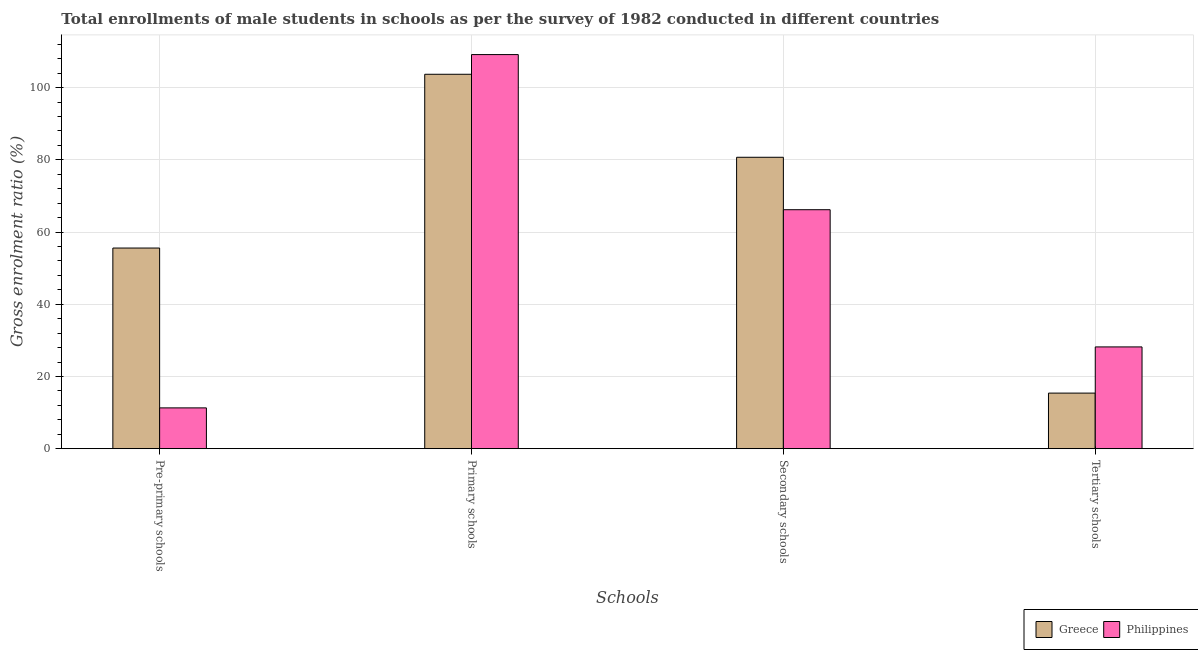How many different coloured bars are there?
Offer a very short reply. 2. How many groups of bars are there?
Make the answer very short. 4. How many bars are there on the 1st tick from the right?
Offer a terse response. 2. What is the label of the 1st group of bars from the left?
Provide a succinct answer. Pre-primary schools. What is the gross enrolment ratio(male) in tertiary schools in Philippines?
Your response must be concise. 28.18. Across all countries, what is the maximum gross enrolment ratio(male) in primary schools?
Provide a succinct answer. 109.14. Across all countries, what is the minimum gross enrolment ratio(male) in secondary schools?
Give a very brief answer. 66.18. In which country was the gross enrolment ratio(male) in primary schools minimum?
Keep it short and to the point. Greece. What is the total gross enrolment ratio(male) in pre-primary schools in the graph?
Provide a succinct answer. 66.86. What is the difference between the gross enrolment ratio(male) in tertiary schools in Philippines and that in Greece?
Give a very brief answer. 12.79. What is the difference between the gross enrolment ratio(male) in secondary schools in Greece and the gross enrolment ratio(male) in pre-primary schools in Philippines?
Your response must be concise. 69.41. What is the average gross enrolment ratio(male) in tertiary schools per country?
Give a very brief answer. 21.79. What is the difference between the gross enrolment ratio(male) in tertiary schools and gross enrolment ratio(male) in secondary schools in Philippines?
Your response must be concise. -38. What is the ratio of the gross enrolment ratio(male) in primary schools in Greece to that in Philippines?
Your answer should be compact. 0.95. Is the gross enrolment ratio(male) in tertiary schools in Philippines less than that in Greece?
Keep it short and to the point. No. Is the difference between the gross enrolment ratio(male) in tertiary schools in Philippines and Greece greater than the difference between the gross enrolment ratio(male) in secondary schools in Philippines and Greece?
Give a very brief answer. Yes. What is the difference between the highest and the second highest gross enrolment ratio(male) in primary schools?
Make the answer very short. 5.46. What is the difference between the highest and the lowest gross enrolment ratio(male) in secondary schools?
Your response must be concise. 14.52. In how many countries, is the gross enrolment ratio(male) in pre-primary schools greater than the average gross enrolment ratio(male) in pre-primary schools taken over all countries?
Your answer should be compact. 1. Is the sum of the gross enrolment ratio(male) in tertiary schools in Greece and Philippines greater than the maximum gross enrolment ratio(male) in primary schools across all countries?
Provide a short and direct response. No. What does the 2nd bar from the left in Tertiary schools represents?
Offer a terse response. Philippines. Is it the case that in every country, the sum of the gross enrolment ratio(male) in pre-primary schools and gross enrolment ratio(male) in primary schools is greater than the gross enrolment ratio(male) in secondary schools?
Give a very brief answer. Yes. What is the difference between two consecutive major ticks on the Y-axis?
Ensure brevity in your answer.  20. Does the graph contain any zero values?
Your response must be concise. No. How many legend labels are there?
Offer a very short reply. 2. What is the title of the graph?
Provide a succinct answer. Total enrollments of male students in schools as per the survey of 1982 conducted in different countries. What is the label or title of the X-axis?
Your answer should be very brief. Schools. What is the label or title of the Y-axis?
Your answer should be compact. Gross enrolment ratio (%). What is the Gross enrolment ratio (%) of Greece in Pre-primary schools?
Offer a terse response. 55.57. What is the Gross enrolment ratio (%) of Philippines in Pre-primary schools?
Offer a terse response. 11.3. What is the Gross enrolment ratio (%) of Greece in Primary schools?
Ensure brevity in your answer.  103.69. What is the Gross enrolment ratio (%) of Philippines in Primary schools?
Your answer should be very brief. 109.14. What is the Gross enrolment ratio (%) of Greece in Secondary schools?
Your answer should be compact. 80.71. What is the Gross enrolment ratio (%) of Philippines in Secondary schools?
Offer a terse response. 66.18. What is the Gross enrolment ratio (%) in Greece in Tertiary schools?
Offer a very short reply. 15.39. What is the Gross enrolment ratio (%) of Philippines in Tertiary schools?
Your answer should be very brief. 28.18. Across all Schools, what is the maximum Gross enrolment ratio (%) in Greece?
Ensure brevity in your answer.  103.69. Across all Schools, what is the maximum Gross enrolment ratio (%) in Philippines?
Give a very brief answer. 109.14. Across all Schools, what is the minimum Gross enrolment ratio (%) in Greece?
Give a very brief answer. 15.39. Across all Schools, what is the minimum Gross enrolment ratio (%) in Philippines?
Provide a short and direct response. 11.3. What is the total Gross enrolment ratio (%) of Greece in the graph?
Give a very brief answer. 255.35. What is the total Gross enrolment ratio (%) of Philippines in the graph?
Keep it short and to the point. 214.81. What is the difference between the Gross enrolment ratio (%) of Greece in Pre-primary schools and that in Primary schools?
Your answer should be very brief. -48.12. What is the difference between the Gross enrolment ratio (%) in Philippines in Pre-primary schools and that in Primary schools?
Offer a terse response. -97.85. What is the difference between the Gross enrolment ratio (%) in Greece in Pre-primary schools and that in Secondary schools?
Your answer should be very brief. -25.14. What is the difference between the Gross enrolment ratio (%) of Philippines in Pre-primary schools and that in Secondary schools?
Make the answer very short. -54.88. What is the difference between the Gross enrolment ratio (%) of Greece in Pre-primary schools and that in Tertiary schools?
Give a very brief answer. 40.17. What is the difference between the Gross enrolment ratio (%) of Philippines in Pre-primary schools and that in Tertiary schools?
Your answer should be compact. -16.89. What is the difference between the Gross enrolment ratio (%) of Greece in Primary schools and that in Secondary schools?
Offer a very short reply. 22.98. What is the difference between the Gross enrolment ratio (%) in Philippines in Primary schools and that in Secondary schools?
Keep it short and to the point. 42.96. What is the difference between the Gross enrolment ratio (%) in Greece in Primary schools and that in Tertiary schools?
Provide a succinct answer. 88.3. What is the difference between the Gross enrolment ratio (%) in Philippines in Primary schools and that in Tertiary schools?
Ensure brevity in your answer.  80.96. What is the difference between the Gross enrolment ratio (%) of Greece in Secondary schools and that in Tertiary schools?
Give a very brief answer. 65.31. What is the difference between the Gross enrolment ratio (%) in Philippines in Secondary schools and that in Tertiary schools?
Offer a terse response. 38. What is the difference between the Gross enrolment ratio (%) of Greece in Pre-primary schools and the Gross enrolment ratio (%) of Philippines in Primary schools?
Your answer should be very brief. -53.58. What is the difference between the Gross enrolment ratio (%) in Greece in Pre-primary schools and the Gross enrolment ratio (%) in Philippines in Secondary schools?
Keep it short and to the point. -10.61. What is the difference between the Gross enrolment ratio (%) of Greece in Pre-primary schools and the Gross enrolment ratio (%) of Philippines in Tertiary schools?
Offer a terse response. 27.38. What is the difference between the Gross enrolment ratio (%) of Greece in Primary schools and the Gross enrolment ratio (%) of Philippines in Secondary schools?
Offer a very short reply. 37.51. What is the difference between the Gross enrolment ratio (%) in Greece in Primary schools and the Gross enrolment ratio (%) in Philippines in Tertiary schools?
Provide a succinct answer. 75.51. What is the difference between the Gross enrolment ratio (%) of Greece in Secondary schools and the Gross enrolment ratio (%) of Philippines in Tertiary schools?
Offer a very short reply. 52.52. What is the average Gross enrolment ratio (%) in Greece per Schools?
Your answer should be compact. 63.84. What is the average Gross enrolment ratio (%) in Philippines per Schools?
Your answer should be very brief. 53.7. What is the difference between the Gross enrolment ratio (%) of Greece and Gross enrolment ratio (%) of Philippines in Pre-primary schools?
Keep it short and to the point. 44.27. What is the difference between the Gross enrolment ratio (%) in Greece and Gross enrolment ratio (%) in Philippines in Primary schools?
Offer a terse response. -5.46. What is the difference between the Gross enrolment ratio (%) of Greece and Gross enrolment ratio (%) of Philippines in Secondary schools?
Your answer should be very brief. 14.52. What is the difference between the Gross enrolment ratio (%) in Greece and Gross enrolment ratio (%) in Philippines in Tertiary schools?
Provide a succinct answer. -12.79. What is the ratio of the Gross enrolment ratio (%) of Greece in Pre-primary schools to that in Primary schools?
Your answer should be very brief. 0.54. What is the ratio of the Gross enrolment ratio (%) in Philippines in Pre-primary schools to that in Primary schools?
Ensure brevity in your answer.  0.1. What is the ratio of the Gross enrolment ratio (%) of Greece in Pre-primary schools to that in Secondary schools?
Provide a succinct answer. 0.69. What is the ratio of the Gross enrolment ratio (%) of Philippines in Pre-primary schools to that in Secondary schools?
Make the answer very short. 0.17. What is the ratio of the Gross enrolment ratio (%) of Greece in Pre-primary schools to that in Tertiary schools?
Offer a terse response. 3.61. What is the ratio of the Gross enrolment ratio (%) of Philippines in Pre-primary schools to that in Tertiary schools?
Your answer should be very brief. 0.4. What is the ratio of the Gross enrolment ratio (%) in Greece in Primary schools to that in Secondary schools?
Provide a succinct answer. 1.28. What is the ratio of the Gross enrolment ratio (%) of Philippines in Primary schools to that in Secondary schools?
Offer a terse response. 1.65. What is the ratio of the Gross enrolment ratio (%) in Greece in Primary schools to that in Tertiary schools?
Give a very brief answer. 6.74. What is the ratio of the Gross enrolment ratio (%) of Philippines in Primary schools to that in Tertiary schools?
Your response must be concise. 3.87. What is the ratio of the Gross enrolment ratio (%) in Greece in Secondary schools to that in Tertiary schools?
Ensure brevity in your answer.  5.24. What is the ratio of the Gross enrolment ratio (%) in Philippines in Secondary schools to that in Tertiary schools?
Keep it short and to the point. 2.35. What is the difference between the highest and the second highest Gross enrolment ratio (%) of Greece?
Your response must be concise. 22.98. What is the difference between the highest and the second highest Gross enrolment ratio (%) in Philippines?
Make the answer very short. 42.96. What is the difference between the highest and the lowest Gross enrolment ratio (%) of Greece?
Give a very brief answer. 88.3. What is the difference between the highest and the lowest Gross enrolment ratio (%) in Philippines?
Give a very brief answer. 97.85. 